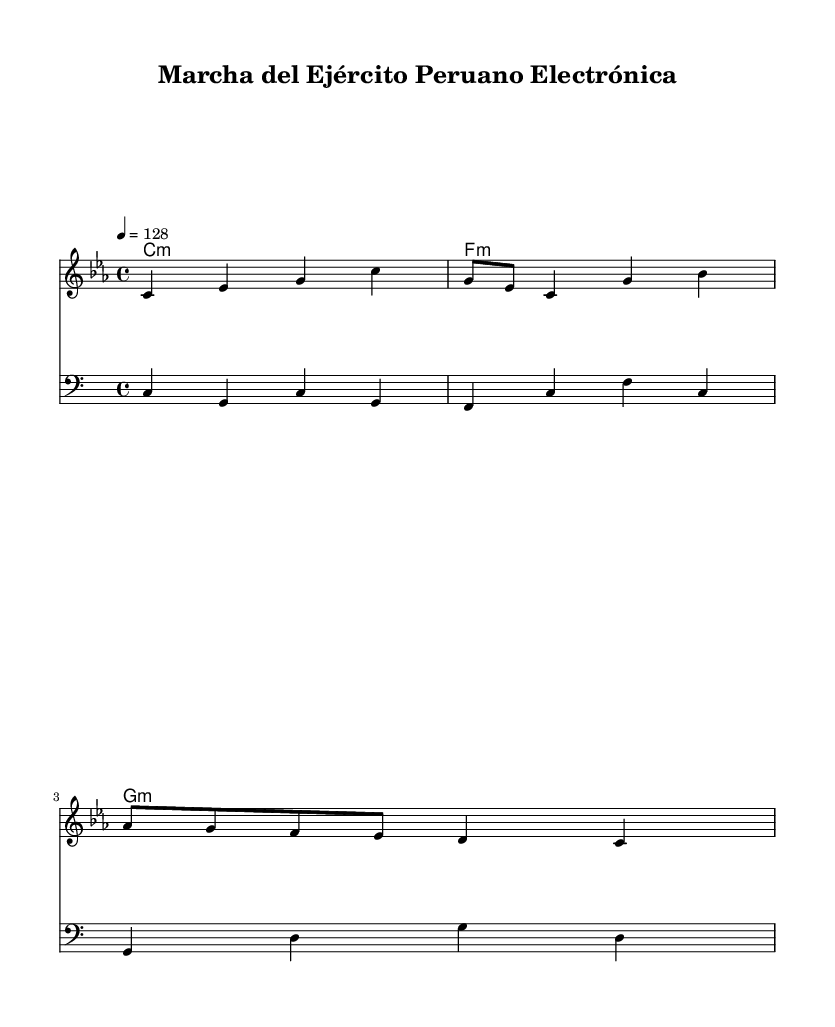What is the key signature of this music? The key signature is C minor, which has three flats (B♭, E♭, and A♭). It is indicated at the beginning of the staff where the key signature is shown.
Answer: C minor What is the time signature of the piece? The time signature is 4/4, which indicates there are four beats in each measure and the quarter note gets one beat. This is visible at the beginning of the score.
Answer: 4/4 What is the tempo marking for this composition? The tempo marking is 4 = 128, meaning that a quarter note is to be played at a speed of 128 beats per minute. This marking is found above the staff at the beginning of the piece.
Answer: 128 How many measures are represented in the melody? The melody contains eight measures. This can be counted by observing the measure lines that separate the notes into distinct groups, starting from the beginning of the melody line.
Answer: 8 What type of music is this arrangement classified as? The arrangement is classified as Electronic. This is inferred from the title "Marcha del Ejército Peruano Electrónica," which specifies that it is an electronic remix of a traditional military march.
Answer: Electronic Which chords are used in the harmony section? The chords used are C minor, F minor, and G minor. These chords are listed in the chord names section under the harmony part, each represented as a single chord marking.
Answer: C minor, F minor, G minor What clef is used for the bass staff? The bass staff uses the bass clef. This can be identified by the specific symbol at the beginning of the bass staff line, which represents the pitches available for that part.
Answer: Bass clef 